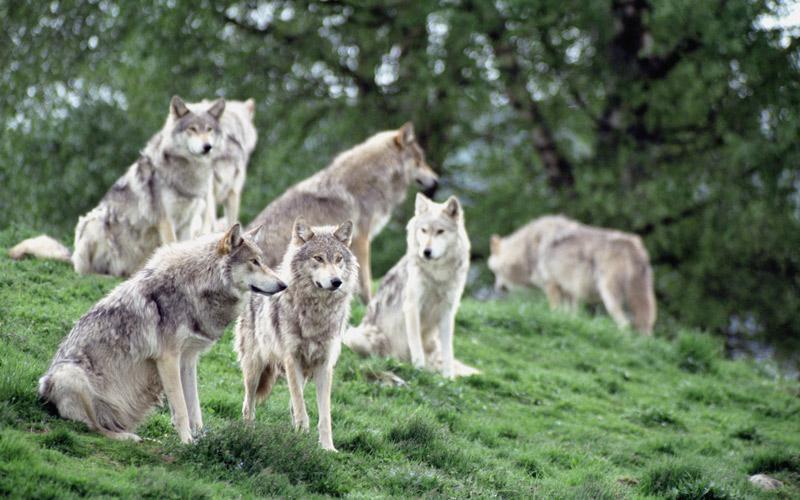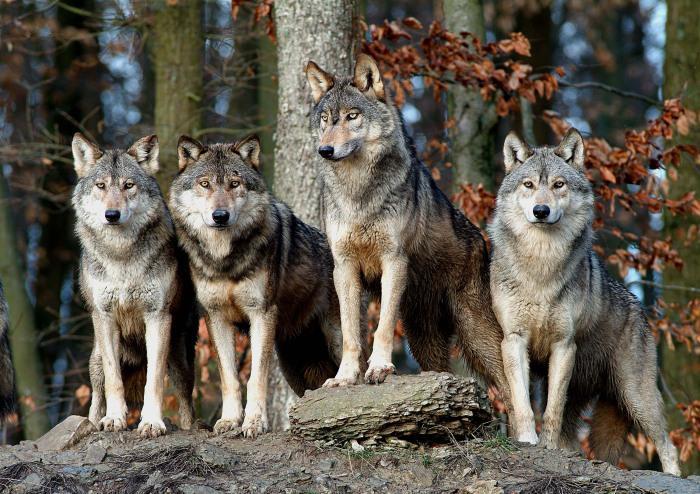The first image is the image on the left, the second image is the image on the right. Evaluate the accuracy of this statement regarding the images: "The right image contains exactly one wolf.". Is it true? Answer yes or no. No. The first image is the image on the left, the second image is the image on the right. For the images shown, is this caption "An image contains exactly four wolves posed similarly and side-by-side." true? Answer yes or no. Yes. 